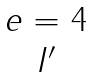<formula> <loc_0><loc_0><loc_500><loc_500>\begin{matrix} e = 4 \\ I ^ { \prime } \end{matrix}</formula> 